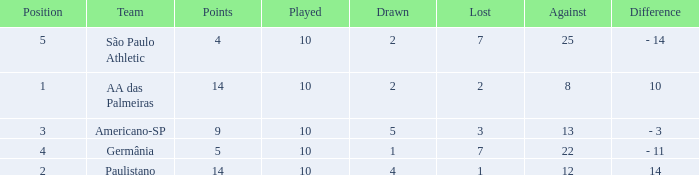What is the sum of Against when the lost is more than 7? None. 